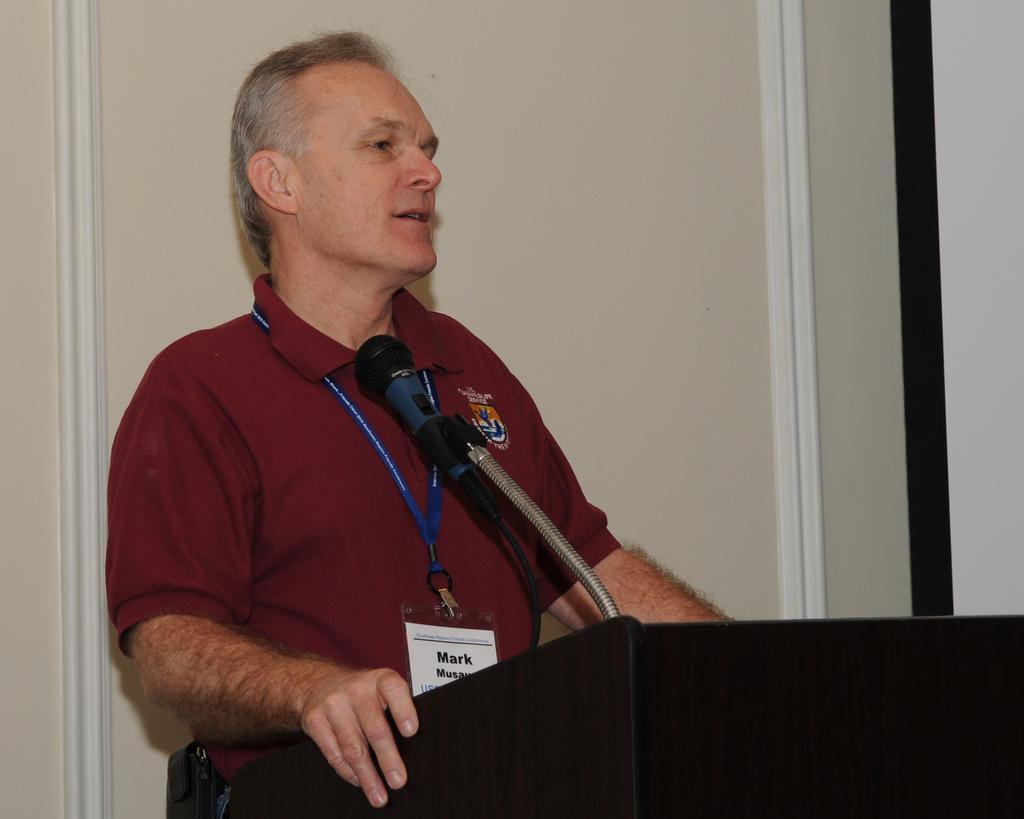Describe this image in one or two sentences. In this image I can see a man is standing and I can see he is wearing a maroon colour t-shirt and an ID card. In the front of him I can see a podium and on it I can see a mic. I can also see something is written on the ID card. 